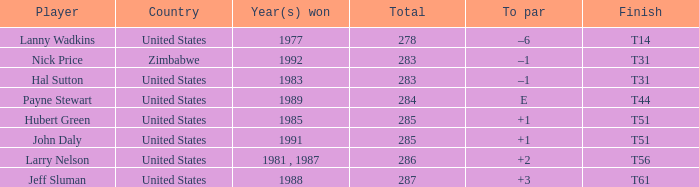In which year(s) was the victory, when the rank is "t31", and when the competitor is "nick price"? 1992.0. 